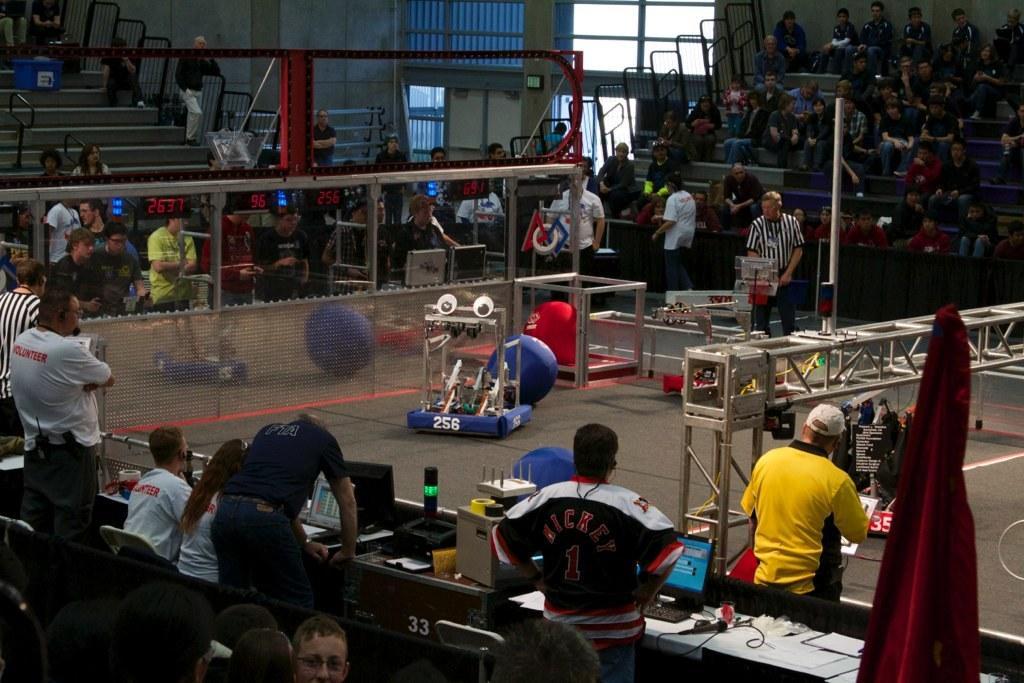Can you describe this image briefly? In this image there are some persons standing at bottom of this image, and there are some tables at bottom of this image and there are some chairs at bottom left corner of this image and there is a fencing wall in middle of this image and there is a sitting area at top of this image and there are some persons are sitting in this area and there is a wall in the background. There is one person standing at right side of this image is wearing yellow color t shirt. 